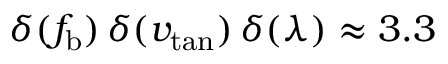Convert formula to latex. <formula><loc_0><loc_0><loc_500><loc_500>\delta ( f _ { b } ) \, \delta ( v _ { t a n } ) \, \delta ( \lambda ) \approx 3 . 3</formula> 